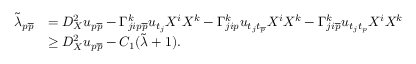Convert formula to latex. <formula><loc_0><loc_0><loc_500><loc_500>\begin{array} { r l } { \tilde { \lambda } _ { p \overline { p } } } & { = D _ { X } ^ { 2 } u _ { p \overline { p } } - \Gamma _ { j i p \overline { p } } ^ { k } u _ { t _ { j } } X ^ { i } X ^ { k } - \Gamma _ { j i p } ^ { k } u _ { t _ { j } t _ { \overline { p } } } X ^ { i } X ^ { k } - \Gamma _ { j i \overline { p } } ^ { k } u _ { t _ { j } t _ { p } } X ^ { i } X ^ { k } } \\ & { \geq D _ { X } ^ { 2 } u _ { p \overline { p } } - C _ { 1 } ( \tilde { \lambda } + 1 ) . } \end{array}</formula> 